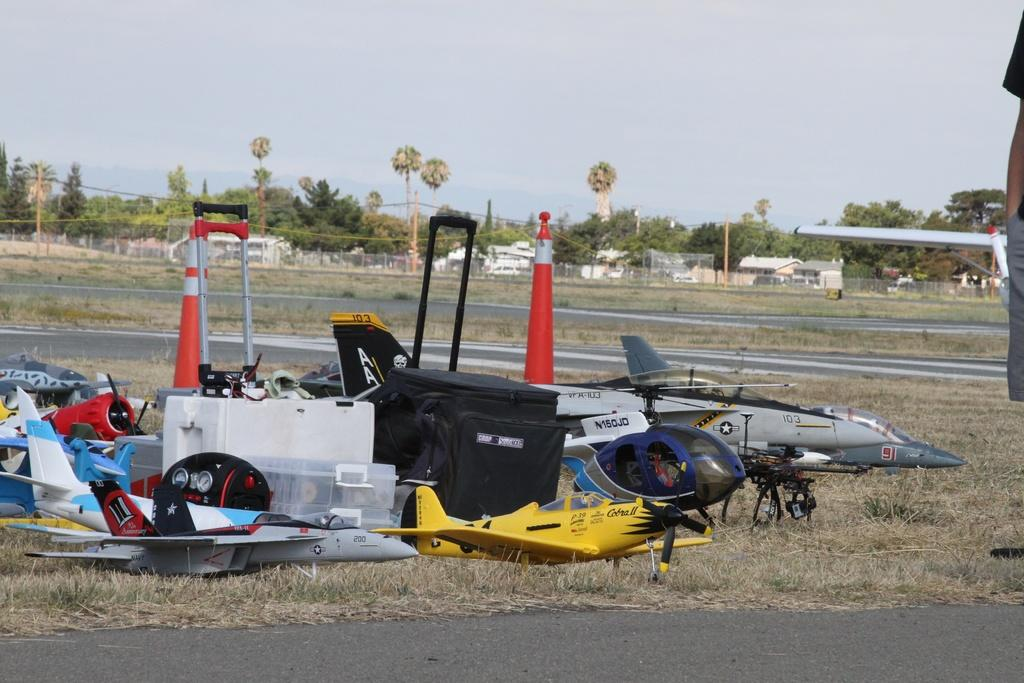<image>
Create a compact narrative representing the image presented. A small airplane on the ground says 103 on it. 